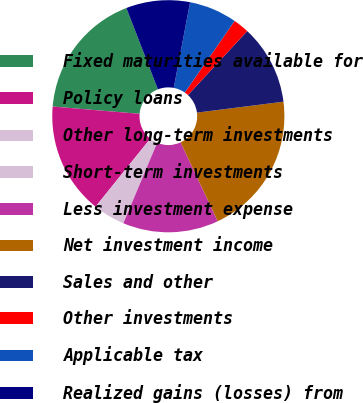Convert chart. <chart><loc_0><loc_0><loc_500><loc_500><pie_chart><fcel>Fixed maturities available for<fcel>Policy loans<fcel>Other long-term investments<fcel>Short-term investments<fcel>Less investment expense<fcel>Net investment income<fcel>Sales and other<fcel>Other investments<fcel>Applicable tax<fcel>Realized gains (losses) from<nl><fcel>17.78%<fcel>15.55%<fcel>4.45%<fcel>0.0%<fcel>13.33%<fcel>20.0%<fcel>11.11%<fcel>2.22%<fcel>6.67%<fcel>8.89%<nl></chart> 